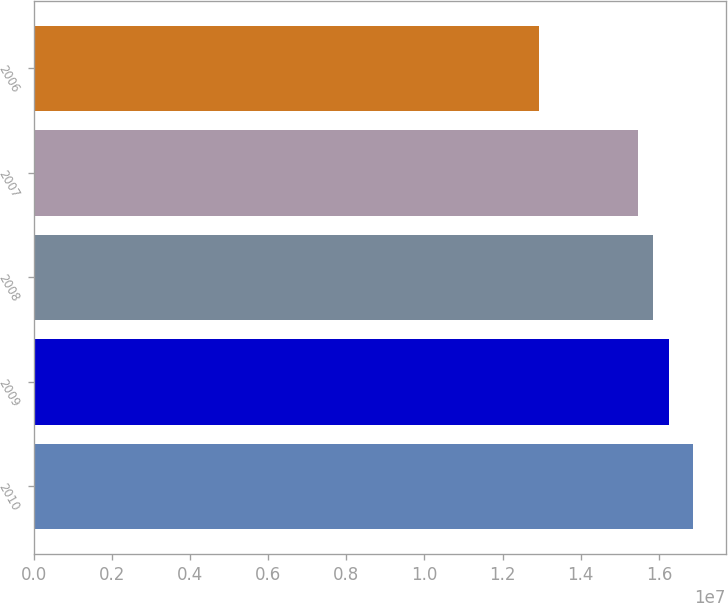<chart> <loc_0><loc_0><loc_500><loc_500><bar_chart><fcel>2010<fcel>2009<fcel>2008<fcel>2007<fcel>2006<nl><fcel>1.6866e+07<fcel>1.62496e+07<fcel>1.58563e+07<fcel>1.5463e+07<fcel>1.2933e+07<nl></chart> 